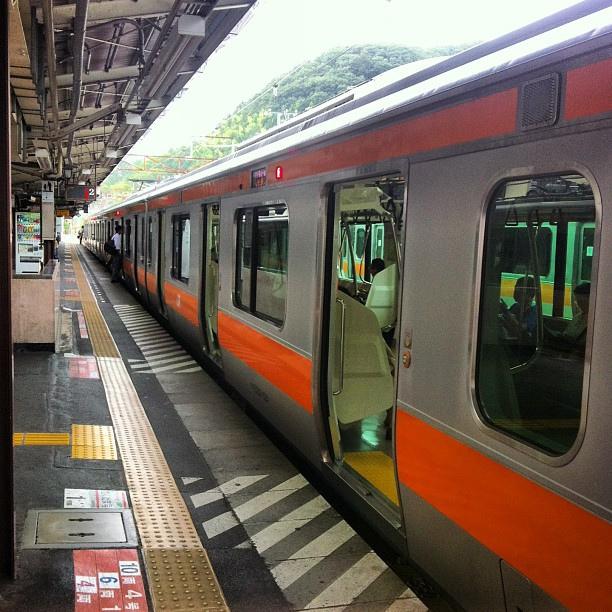Are there any people on the train?
Quick response, please. Yes. What colors is this train?
Give a very brief answer. Red and gray. Is anyone waiting on the train?
Short answer required. No. 